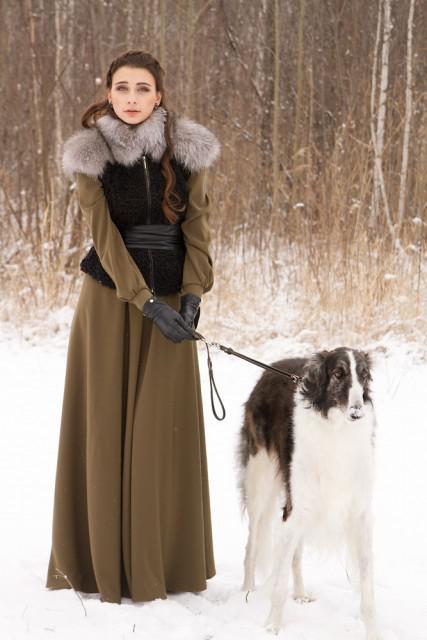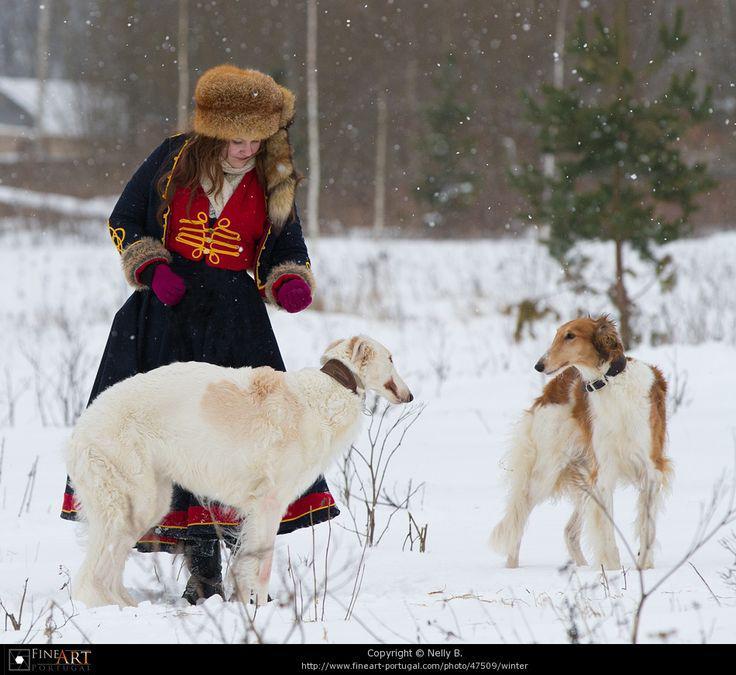The first image is the image on the left, the second image is the image on the right. Analyze the images presented: Is the assertion "A woman is holding a single dog on a leash." valid? Answer yes or no. Yes. The first image is the image on the left, the second image is the image on the right. Assess this claim about the two images: "The right image contains exactly two dogs.". Correct or not? Answer yes or no. Yes. 